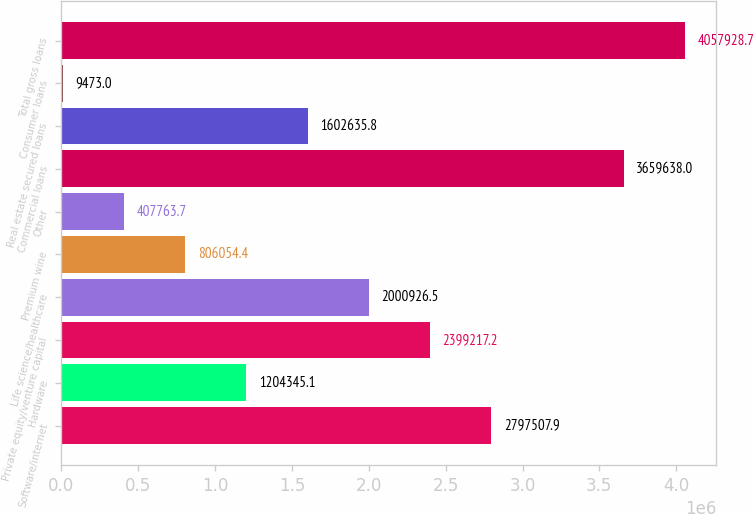Convert chart. <chart><loc_0><loc_0><loc_500><loc_500><bar_chart><fcel>Software/internet<fcel>Hardware<fcel>Private equity/venture capital<fcel>Life science/healthcare<fcel>Premium wine<fcel>Other<fcel>Commercial loans<fcel>Real estate secured loans<fcel>Consumer loans<fcel>Total gross loans<nl><fcel>2.79751e+06<fcel>1.20435e+06<fcel>2.39922e+06<fcel>2.00093e+06<fcel>806054<fcel>407764<fcel>3.65964e+06<fcel>1.60264e+06<fcel>9473<fcel>4.05793e+06<nl></chart> 